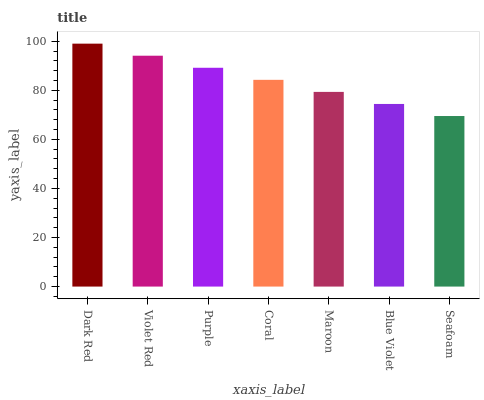Is Seafoam the minimum?
Answer yes or no. Yes. Is Dark Red the maximum?
Answer yes or no. Yes. Is Violet Red the minimum?
Answer yes or no. No. Is Violet Red the maximum?
Answer yes or no. No. Is Dark Red greater than Violet Red?
Answer yes or no. Yes. Is Violet Red less than Dark Red?
Answer yes or no. Yes. Is Violet Red greater than Dark Red?
Answer yes or no. No. Is Dark Red less than Violet Red?
Answer yes or no. No. Is Coral the high median?
Answer yes or no. Yes. Is Coral the low median?
Answer yes or no. Yes. Is Purple the high median?
Answer yes or no. No. Is Violet Red the low median?
Answer yes or no. No. 